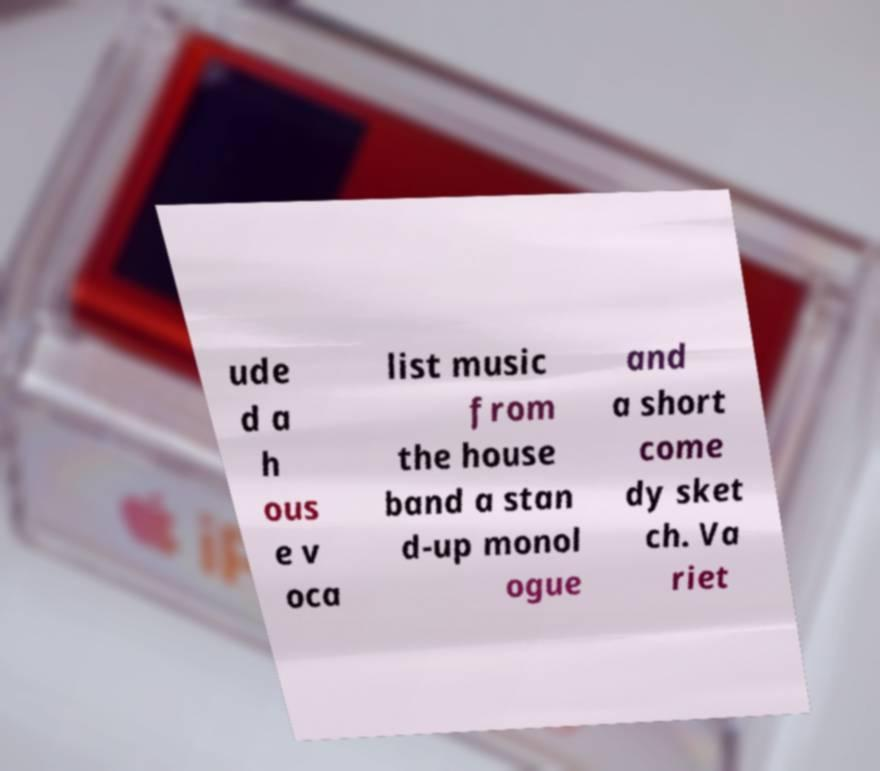For documentation purposes, I need the text within this image transcribed. Could you provide that? ude d a h ous e v oca list music from the house band a stan d-up monol ogue and a short come dy sket ch. Va riet 